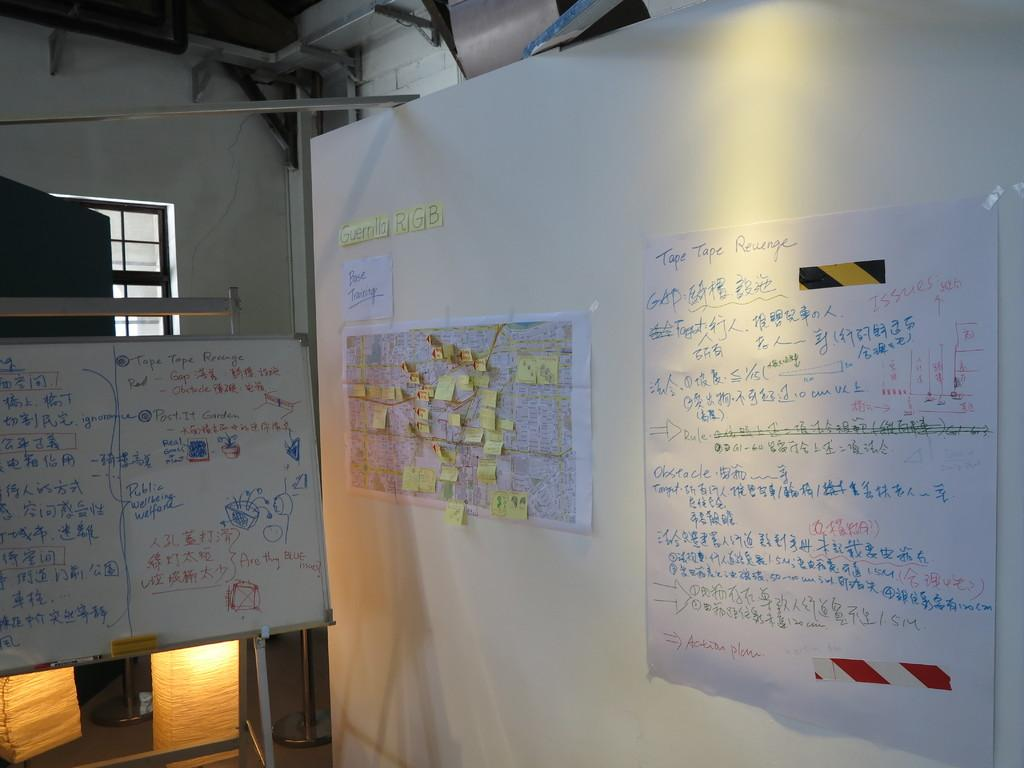Provide a one-sentence caption for the provided image. A white board and posters on the wall make up a plan for Tape Tape Revenge. 